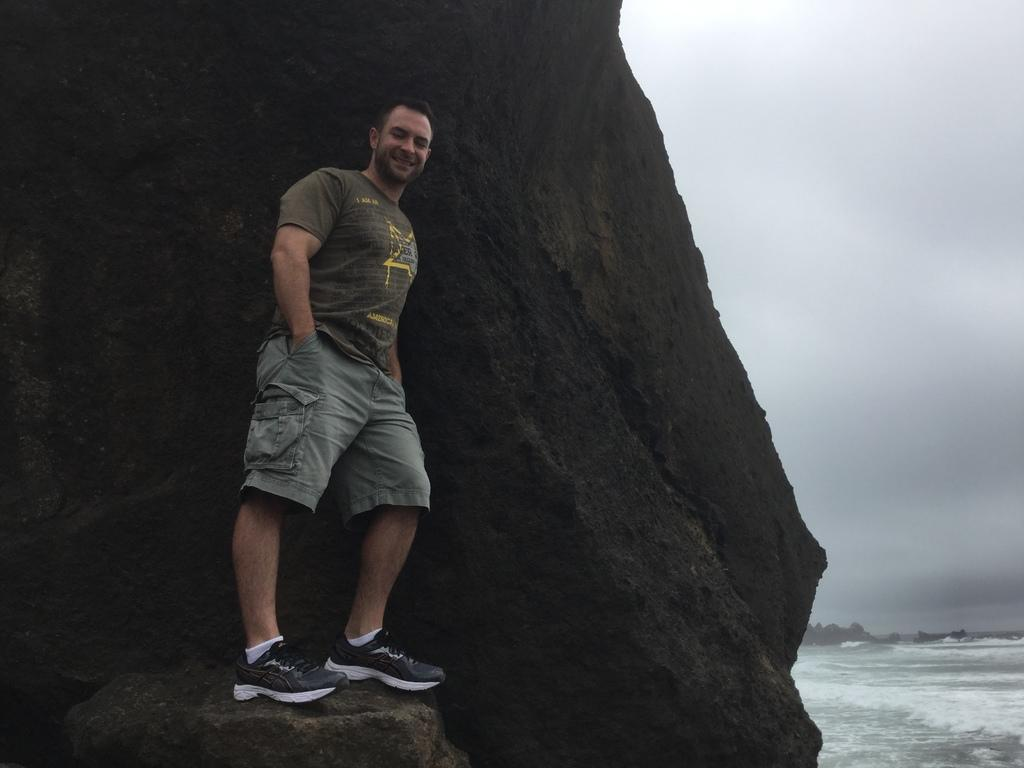What is the man doing in the image? The man is standing on a stone at the rock on the left side of the image. What can be seen on the right side of the image? There is water and trees visible on the right side of the image. What is visible in the sky in the image? The sky is visible, and clouds are present in the sky. What type of cub is playing with the man in the image? There is no cub present in the image; the man is standing alone on a stone at the rock. 